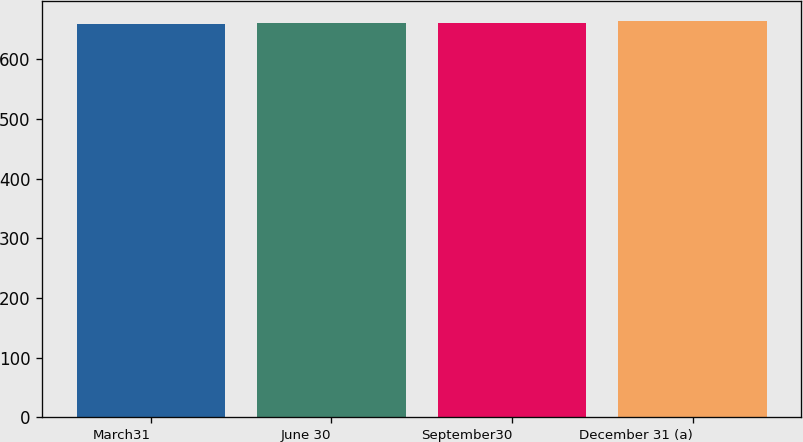Convert chart to OTSL. <chart><loc_0><loc_0><loc_500><loc_500><bar_chart><fcel>March31<fcel>June 30<fcel>September30<fcel>December 31 (a)<nl><fcel>659<fcel>661<fcel>661.5<fcel>664<nl></chart> 